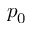<formula> <loc_0><loc_0><loc_500><loc_500>p _ { 0 }</formula> 